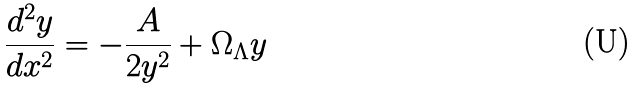Convert formula to latex. <formula><loc_0><loc_0><loc_500><loc_500>\frac { d ^ { 2 } y } { d x ^ { 2 } } = - \frac { A } { 2 y ^ { 2 } } + \Omega _ { \Lambda } y</formula> 